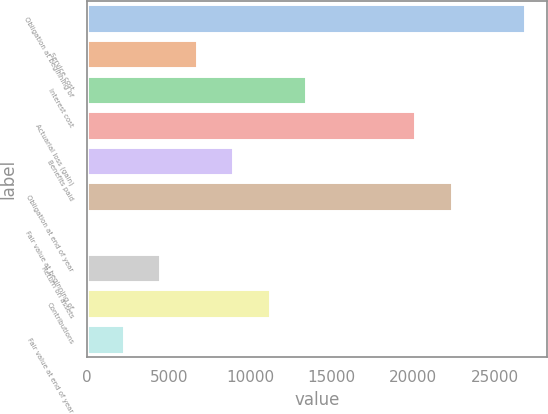<chart> <loc_0><loc_0><loc_500><loc_500><bar_chart><fcel>Obligation at beginning of<fcel>Service cost<fcel>Interest cost<fcel>Actuarial loss (gain)<fcel>Benefits paid<fcel>Obligation at end of year<fcel>Fair value at beginning of<fcel>Return on assets<fcel>Contributions<fcel>Fair value at end of year<nl><fcel>26840.4<fcel>6710.2<fcel>13420.2<fcel>20130.3<fcel>8946.89<fcel>22367<fcel>0.15<fcel>4473.52<fcel>11183.6<fcel>2236.84<nl></chart> 